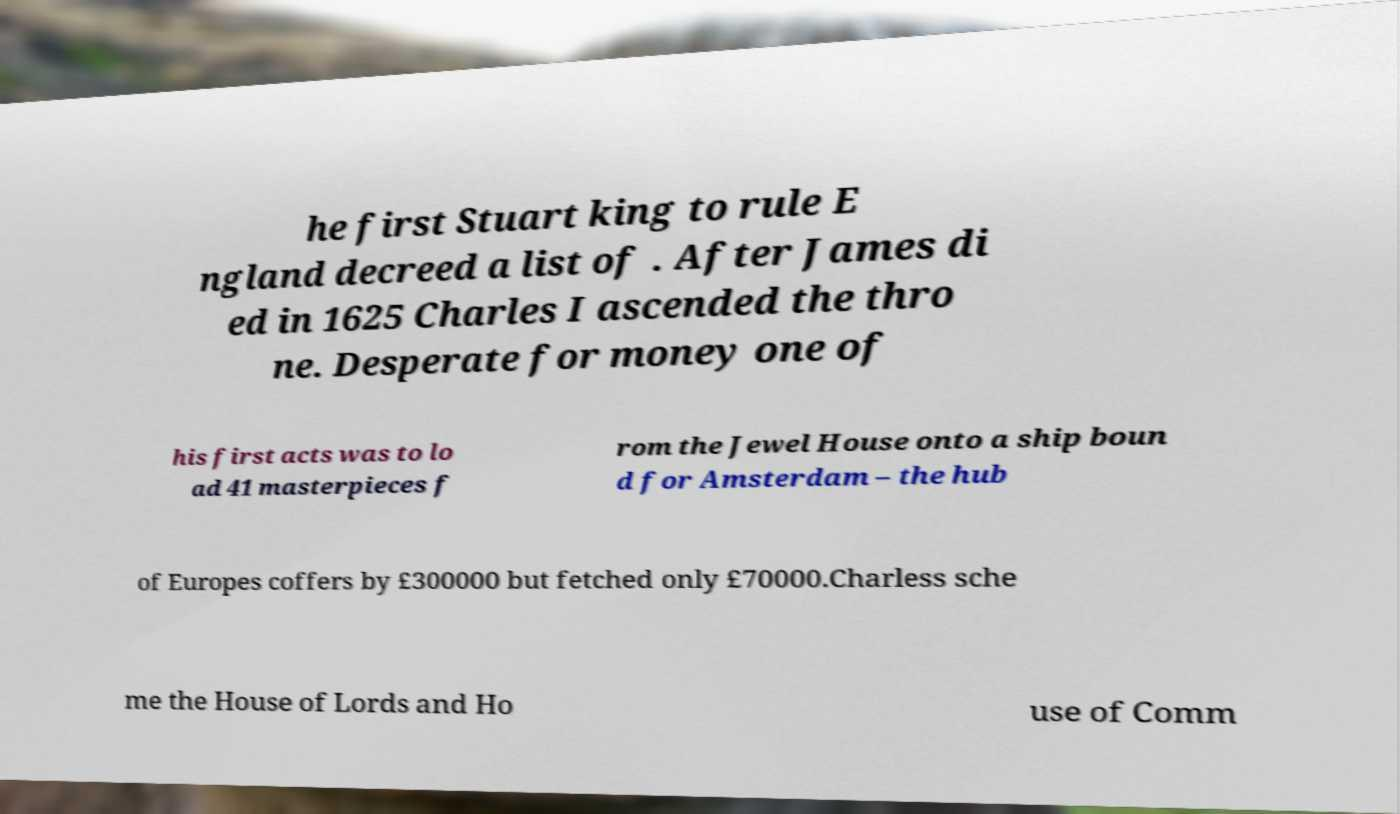What messages or text are displayed in this image? I need them in a readable, typed format. he first Stuart king to rule E ngland decreed a list of . After James di ed in 1625 Charles I ascended the thro ne. Desperate for money one of his first acts was to lo ad 41 masterpieces f rom the Jewel House onto a ship boun d for Amsterdam – the hub of Europes coffers by £300000 but fetched only £70000.Charless sche me the House of Lords and Ho use of Comm 